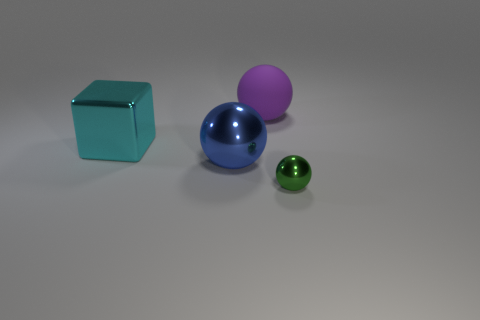There is a metallic object that is on the right side of the big cyan metallic cube and to the left of the green shiny sphere; what shape is it?
Your answer should be compact. Sphere. How many objects are large balls on the left side of the purple object or metallic spheres that are to the left of the green ball?
Offer a terse response. 1. Is the number of small green metal balls on the left side of the small thing the same as the number of large cyan shiny cubes that are behind the cyan metal object?
Offer a terse response. Yes. What shape is the thing that is left of the metallic sphere that is on the left side of the tiny metal ball?
Give a very brief answer. Cube. Is there a cyan thing that has the same shape as the green object?
Make the answer very short. No. How many yellow blocks are there?
Your response must be concise. 0. Does the object right of the big rubber object have the same material as the cyan object?
Offer a very short reply. Yes. Are there any other things that have the same size as the blue object?
Give a very brief answer. Yes. There is a green object; is it the same shape as the big metal object in front of the shiny block?
Provide a short and direct response. Yes. Are there any purple matte objects that are in front of the thing that is on the right side of the big purple rubber ball behind the large blue shiny thing?
Your answer should be compact. No. 